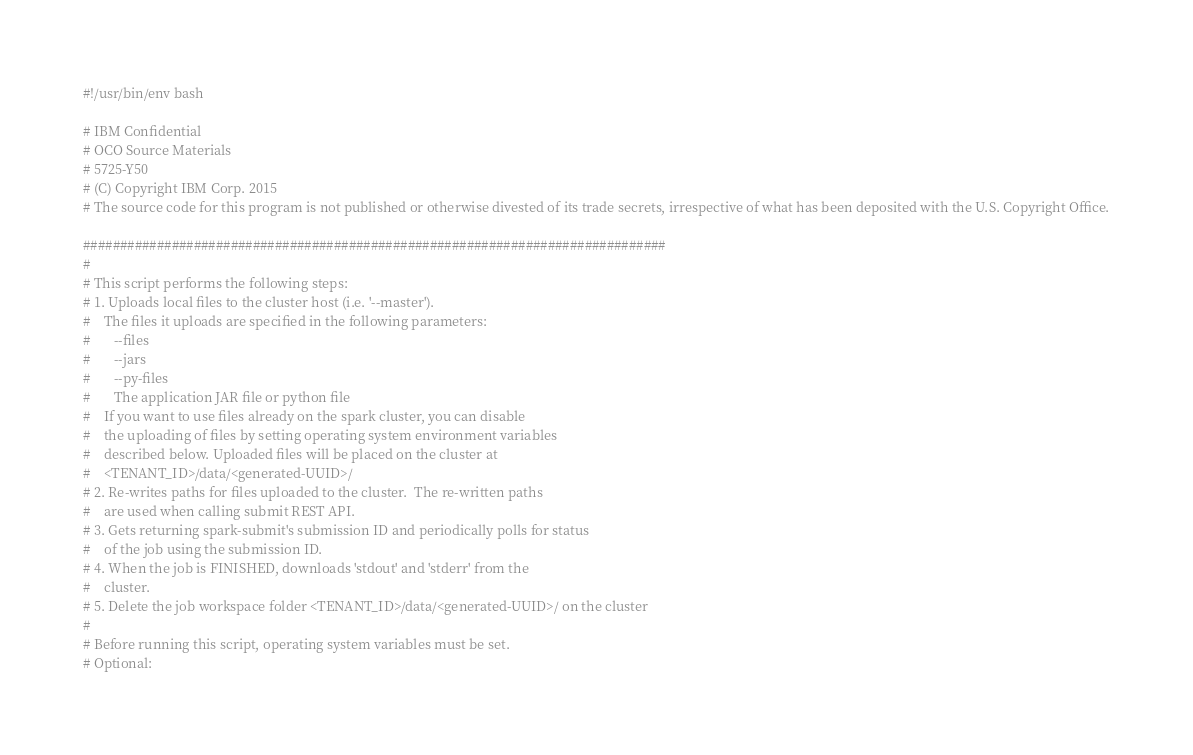<code> <loc_0><loc_0><loc_500><loc_500><_Bash_>#!/usr/bin/env bash

# IBM Confidential
# OCO Source Materials
# 5725-Y50
# (C) Copyright IBM Corp. 2015
# The source code for this program is not published or otherwise divested of its trade secrets, irrespective of what has been deposited with the U.S. Copyright Office.

###############################################################################
#
# This script performs the following steps:
# 1. Uploads local files to the cluster host (i.e. '--master').
#    The files it uploads are specified in the following parameters:
#       --files
#       --jars
#       --py-files
#       The application JAR file or python file
#    If you want to use files already on the spark cluster, you can disable
#    the uploading of files by setting operating system environment variables
#    described below. Uploaded files will be placed on the cluster at
#    <TENANT_ID>/data/<generated-UUID>/
# 2. Re-writes paths for files uploaded to the cluster.  The re-written paths
#    are used when calling submit REST API.
# 3. Gets returning spark-submit's submission ID and periodically polls for status
#    of the job using the submission ID.
# 4. When the job is FINISHED, downloads 'stdout' and 'stderr' from the
#    cluster.
# 5. Delete the job workspace folder <TENANT_ID>/data/<generated-UUID>/ on the cluster
#
# Before running this script, operating system variables must be set.
# Optional:</code> 